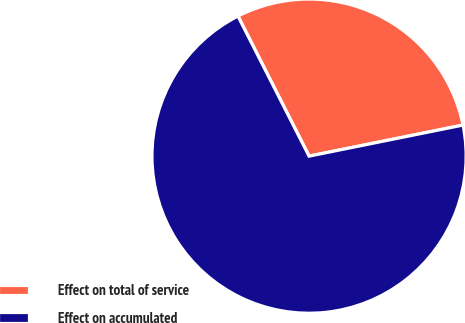Convert chart to OTSL. <chart><loc_0><loc_0><loc_500><loc_500><pie_chart><fcel>Effect on total of service<fcel>Effect on accumulated<nl><fcel>29.31%<fcel>70.69%<nl></chart> 